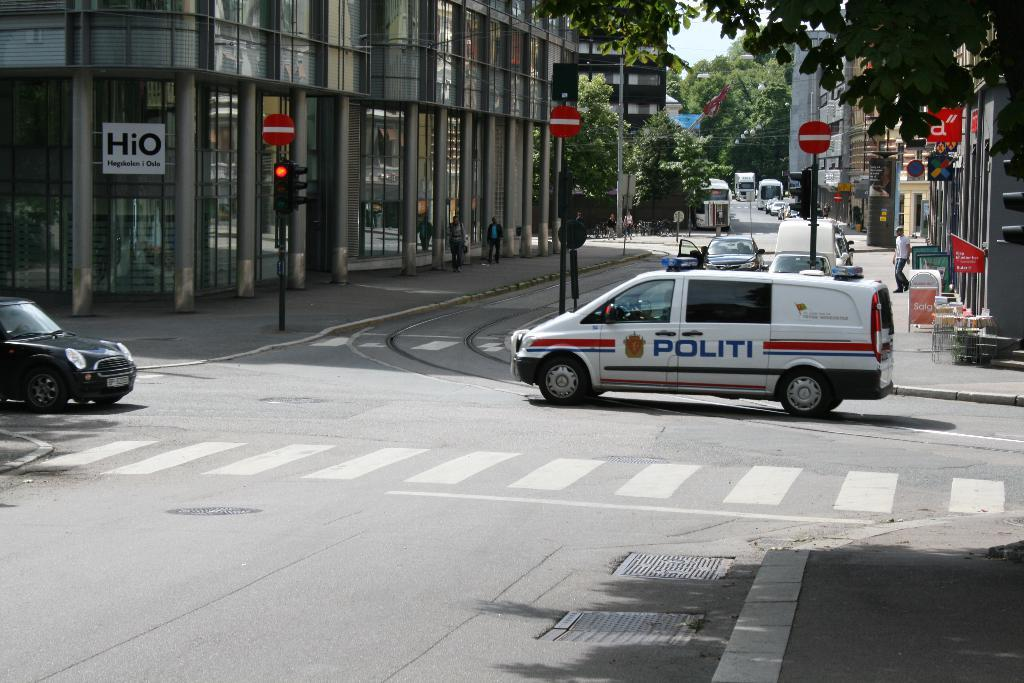What can be seen on the road in the image? There are vehicles on the road in the image. What is visible in the background of the image? In the background of the image, there are buildings, people, poles, boards, traffic signals, vehicles, roads, walkways, trees, and other unspecified things. What industry is being suggested by the presence of the vehicles in the image? The image does not suggest any specific industry; it simply shows vehicles on the road and various elements in the background. 